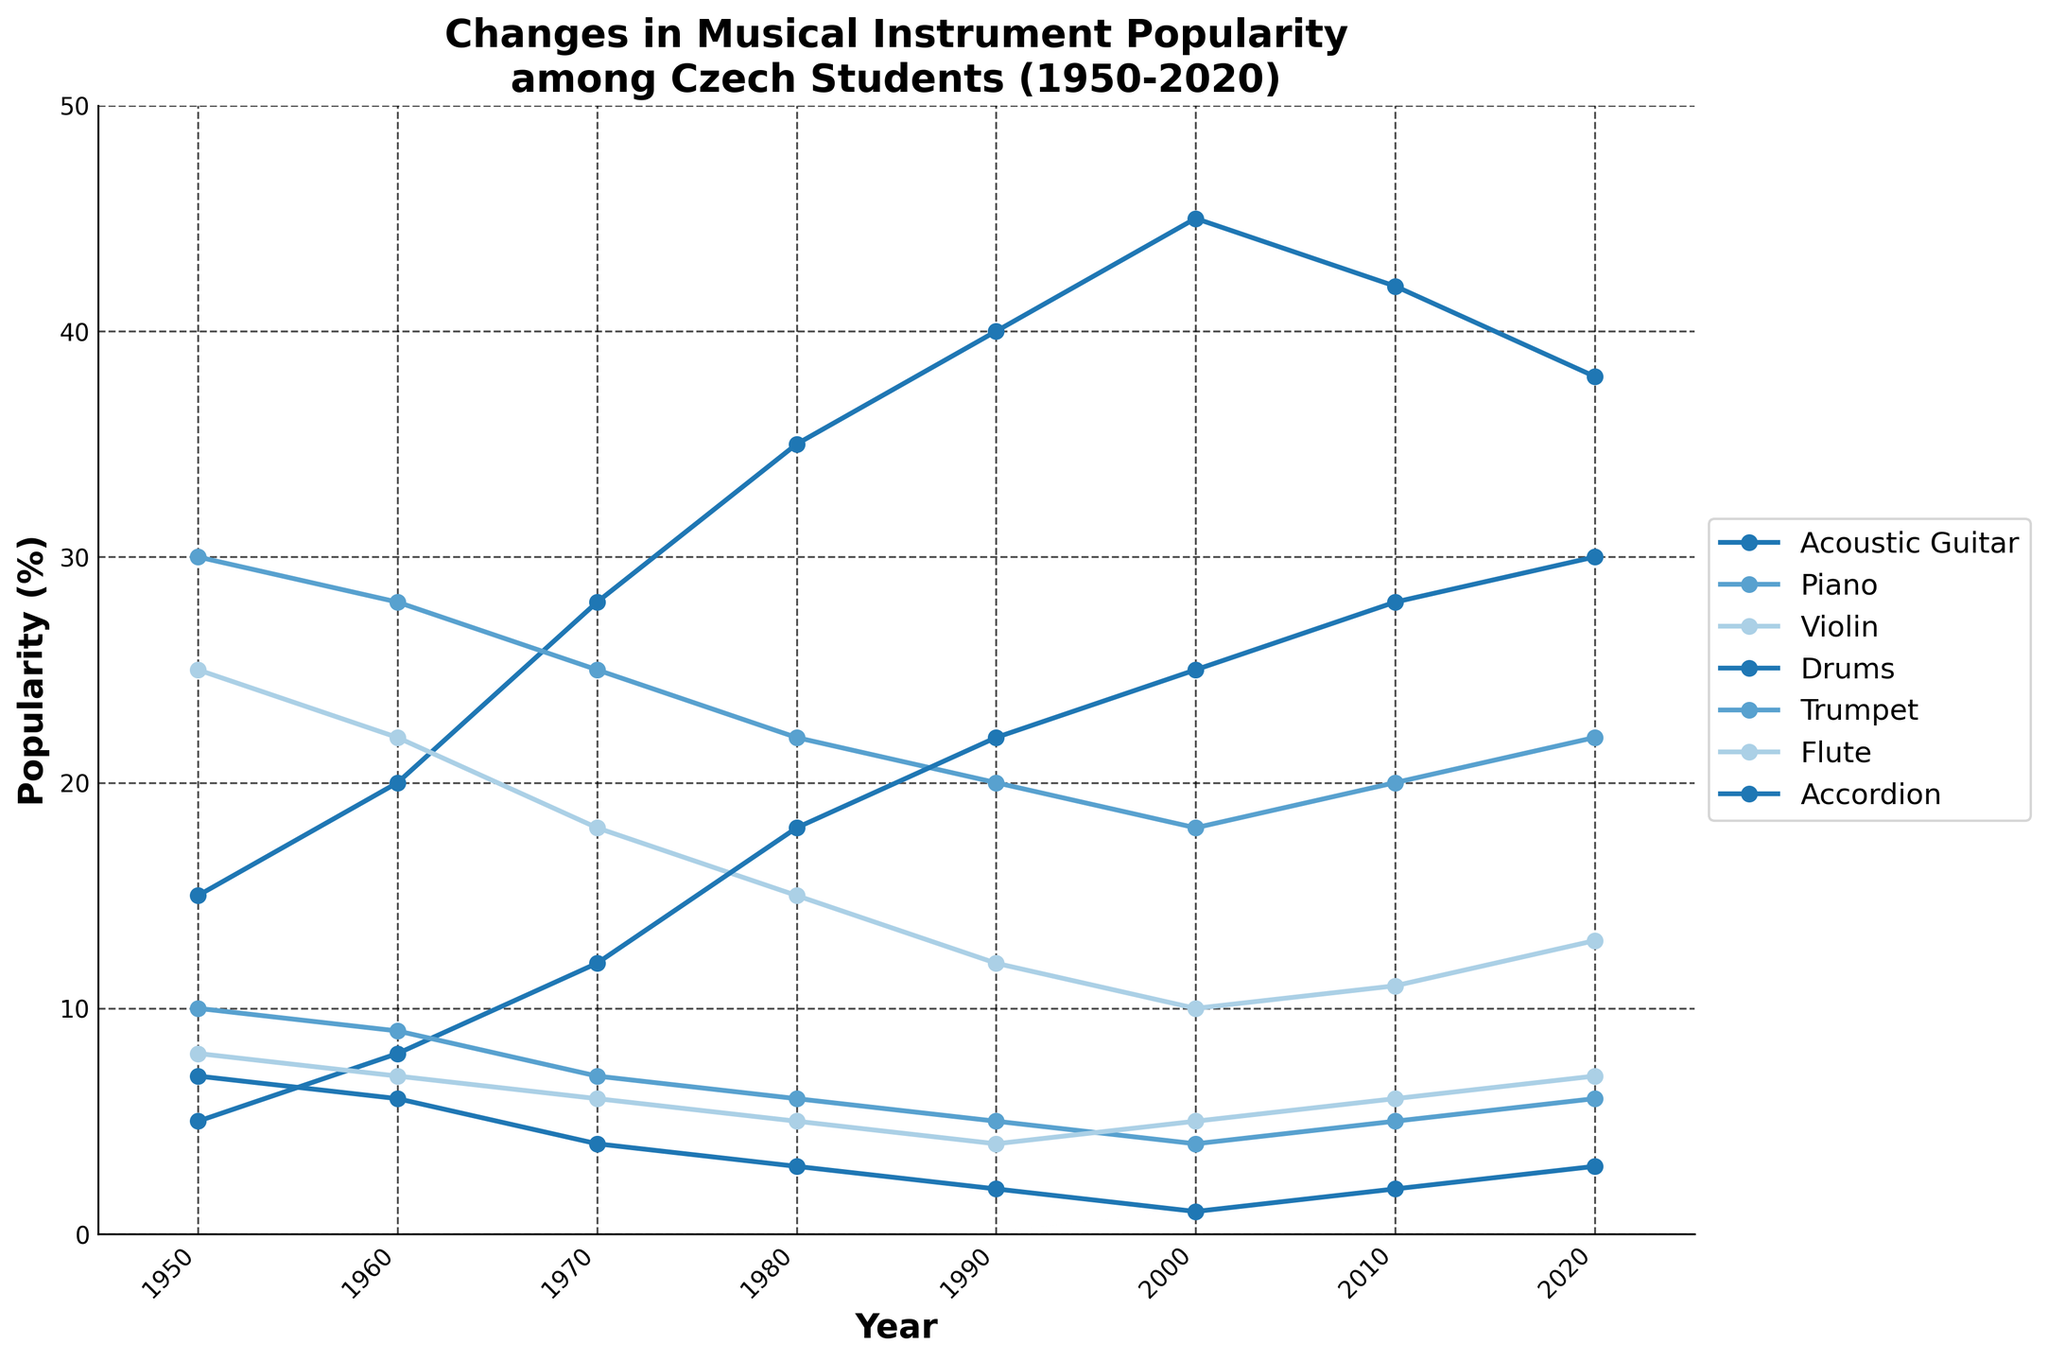What musical instrument had the highest popularity among Czech students in 1980? In 1980, the instrument with the highest popularity can be identified by finding the peak value for that year from all instrument lines. The acoustic guitar had the highest value at 35%.
Answer: Acoustic Guitar Which instrument showed a continuous increase in popularity from 1950 to 2000 before slightly declining? By examining the trend lines, we can see that the Acoustic Guitar's popularity steadily increased from 15% in 1950 to 45% in 2000 before dipping to 42% in 2010.
Answer: Acoustic Guitar Calculate the average popularity of the Piano from 1950 to 2020. To find the average, sum the Piano values (30+28+25+22+20+18+20+22) = 185 and divide by the number of years (8). The average is 185/8 = 23.125.
Answer: 23.125 Which two instruments had approximately equal popularity in 1960? Looking at the 1960 values, Piano had 28% and Violin had 22%. These two are the closest in popularity that year.
Answer: Piano and Violin In what year did the Drum's popularity surpass that of the Violin for the first time? By examining both trend lines, the Drum's popularity overtakes the Violin's between 1970 and 1980. In 1980, Drums were at 18% and Violin at 15%. This is the first year of surpassing.
Answer: 1980 Based on trends from 1950 to 2020, which instrument showed the most significant decline in popularity? The trend of the Violin indicates a significant drop from 25% in 1950 to 13% in 2020, signifying it had the steepest decline among all instruments.
Answer: Violin Compare the popularity of the Flute and the Trumpet in 2020. Which one was more popular? By checking the 2020 values, the Flute was at 7% and the Trumpet was at 6%. The Flute was more popular.
Answer: Flute If we combine the popularity of Drums and Accordion in 1950, is the sum less than or greater than the popularity of the Piano in the same year? Adding Drums and Accordion values for 1950 gives (5+7) = 12%. The Piano's popularity was 30%, which is greater than the sum.
Answer: Greater In which decades did the popularity of the Accordion remain below 5%? Accoridon popularity drops below 5% in the decade of 1980 and stays below through 1990, 2000, 2010, and 2020.
Answer: 1980s, 1990s, 2000s, 2010s, 2020s Which instrument experienced the least change in popularity from 2000 to 2020? By examining the differences between 2000 and 2020 values, the Trumpet changed from 4% to 6%, a change of only 2%, making it the instrument with the least change.
Answer: Trumpet 